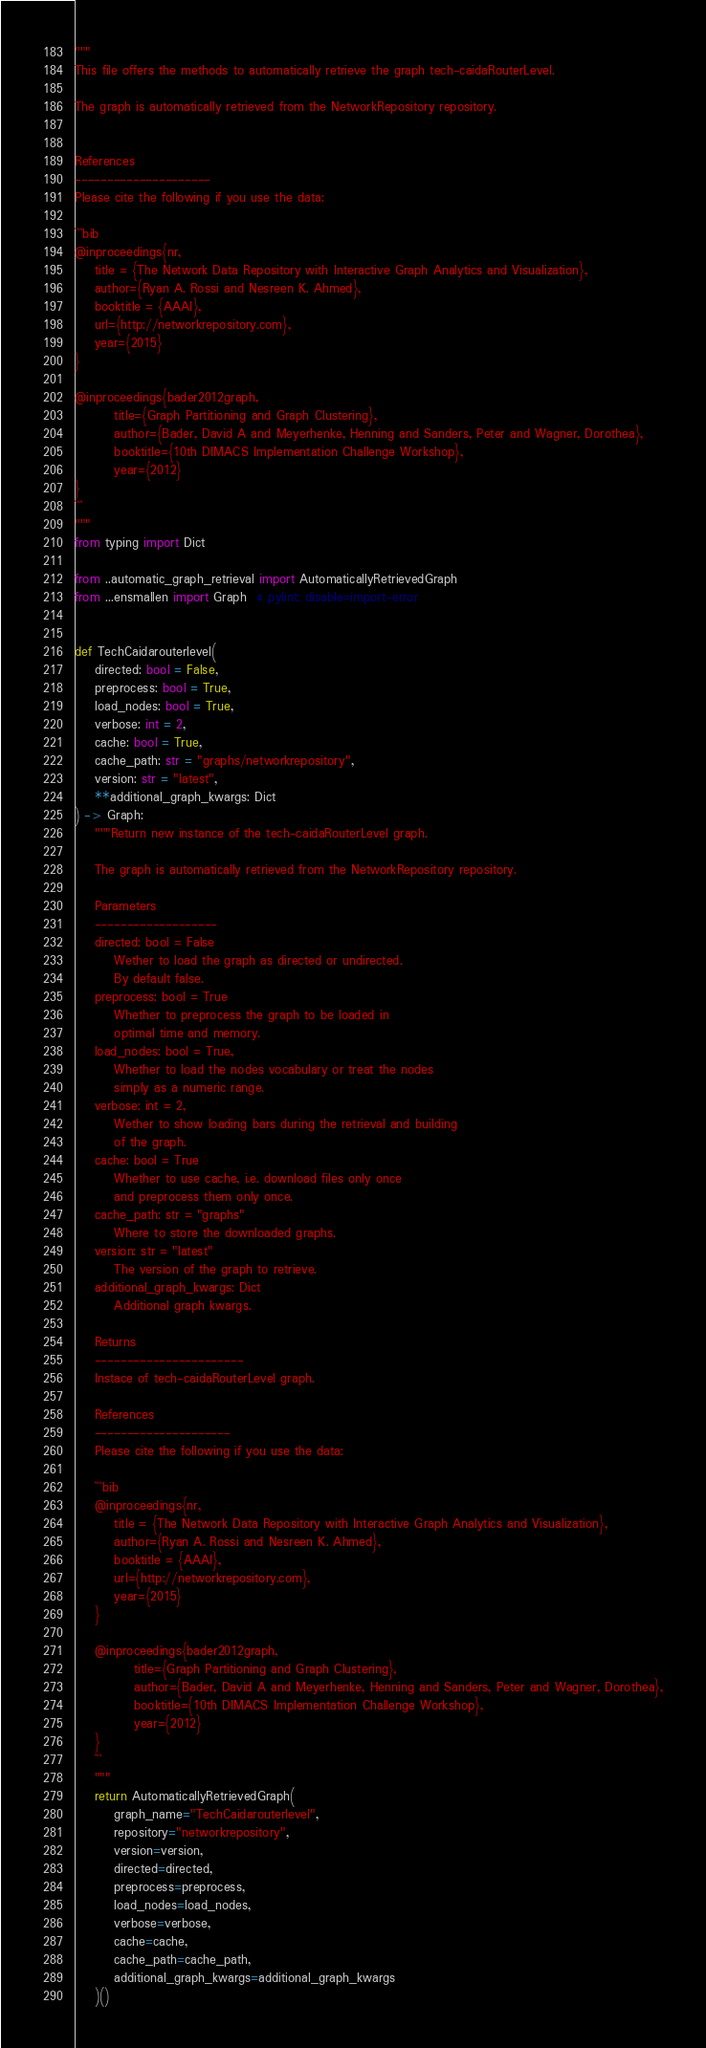Convert code to text. <code><loc_0><loc_0><loc_500><loc_500><_Python_>"""
This file offers the methods to automatically retrieve the graph tech-caidaRouterLevel.

The graph is automatically retrieved from the NetworkRepository repository. 


References
---------------------
Please cite the following if you use the data:

```bib
@inproceedings{nr,
    title = {The Network Data Repository with Interactive Graph Analytics and Visualization},
    author={Ryan A. Rossi and Nesreen K. Ahmed},
    booktitle = {AAAI},
    url={http://networkrepository.com},
    year={2015}
}

@inproceedings{bader2012graph,
        title={Graph Partitioning and Graph Clustering},
        author={Bader, David A and Meyerhenke, Henning and Sanders, Peter and Wagner, Dorothea},
        booktitle={10th DIMACS Implementation Challenge Workshop},
        year={2012}
}
```
"""
from typing import Dict

from ..automatic_graph_retrieval import AutomaticallyRetrievedGraph
from ...ensmallen import Graph  # pylint: disable=import-error


def TechCaidarouterlevel(
    directed: bool = False,
    preprocess: bool = True,
    load_nodes: bool = True,
    verbose: int = 2,
    cache: bool = True,
    cache_path: str = "graphs/networkrepository",
    version: str = "latest",
    **additional_graph_kwargs: Dict
) -> Graph:
    """Return new instance of the tech-caidaRouterLevel graph.

    The graph is automatically retrieved from the NetworkRepository repository.	

    Parameters
    -------------------
    directed: bool = False
        Wether to load the graph as directed or undirected.
        By default false.
    preprocess: bool = True
        Whether to preprocess the graph to be loaded in 
        optimal time and memory.
    load_nodes: bool = True,
        Whether to load the nodes vocabulary or treat the nodes
        simply as a numeric range.
    verbose: int = 2,
        Wether to show loading bars during the retrieval and building
        of the graph.
    cache: bool = True
        Whether to use cache, i.e. download files only once
        and preprocess them only once.
    cache_path: str = "graphs"
        Where to store the downloaded graphs.
    version: str = "latest"
        The version of the graph to retrieve.	
    additional_graph_kwargs: Dict
        Additional graph kwargs.

    Returns
    -----------------------
    Instace of tech-caidaRouterLevel graph.

	References
	---------------------
	Please cite the following if you use the data:
	
	```bib
	@inproceedings{nr,
	    title = {The Network Data Repository with Interactive Graph Analytics and Visualization},
	    author={Ryan A. Rossi and Nesreen K. Ahmed},
	    booktitle = {AAAI},
	    url={http://networkrepository.com},
	    year={2015}
	}
	
	@inproceedings{bader2012graph,
	        title={Graph Partitioning and Graph Clustering},
	        author={Bader, David A and Meyerhenke, Henning and Sanders, Peter and Wagner, Dorothea},
	        booktitle={10th DIMACS Implementation Challenge Workshop},
	        year={2012}
	}
	```
    """
    return AutomaticallyRetrievedGraph(
        graph_name="TechCaidarouterlevel",
        repository="networkrepository",
        version=version,
        directed=directed,
        preprocess=preprocess,
        load_nodes=load_nodes,
        verbose=verbose,
        cache=cache,
        cache_path=cache_path,
        additional_graph_kwargs=additional_graph_kwargs
    )()
</code> 